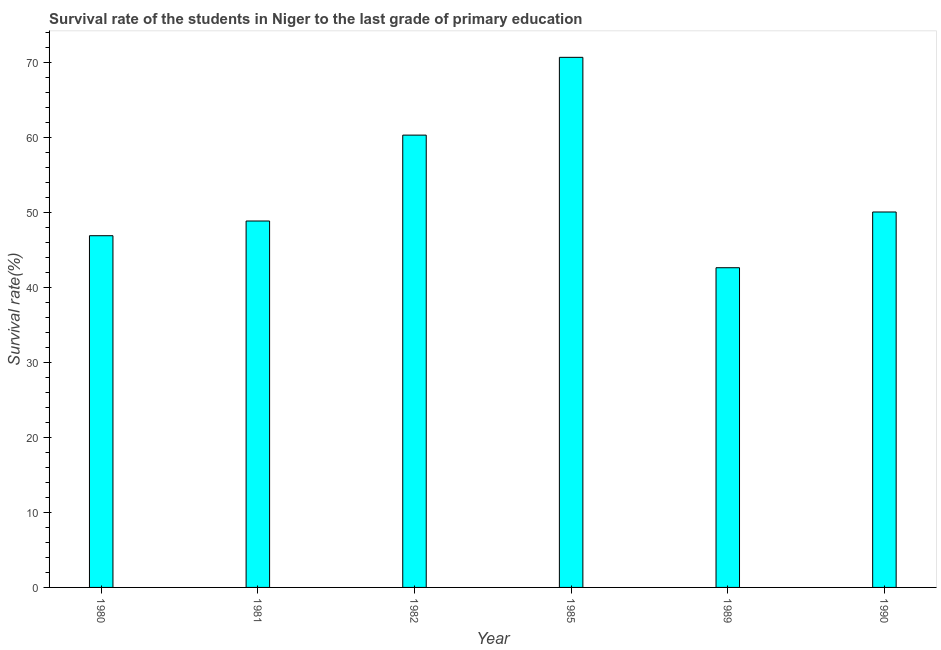Does the graph contain any zero values?
Ensure brevity in your answer.  No. What is the title of the graph?
Provide a short and direct response. Survival rate of the students in Niger to the last grade of primary education. What is the label or title of the X-axis?
Your answer should be very brief. Year. What is the label or title of the Y-axis?
Your answer should be compact. Survival rate(%). What is the survival rate in primary education in 1990?
Provide a succinct answer. 50.06. Across all years, what is the maximum survival rate in primary education?
Provide a succinct answer. 70.68. Across all years, what is the minimum survival rate in primary education?
Provide a short and direct response. 42.63. In which year was the survival rate in primary education minimum?
Your answer should be compact. 1989. What is the sum of the survival rate in primary education?
Offer a very short reply. 319.42. What is the difference between the survival rate in primary education in 1980 and 1982?
Your response must be concise. -13.41. What is the average survival rate in primary education per year?
Keep it short and to the point. 53.24. What is the median survival rate in primary education?
Your response must be concise. 49.46. In how many years, is the survival rate in primary education greater than 4 %?
Offer a very short reply. 6. What is the ratio of the survival rate in primary education in 1980 to that in 1982?
Your response must be concise. 0.78. Is the difference between the survival rate in primary education in 1981 and 1989 greater than the difference between any two years?
Give a very brief answer. No. What is the difference between the highest and the second highest survival rate in primary education?
Ensure brevity in your answer.  10.37. Is the sum of the survival rate in primary education in 1981 and 1982 greater than the maximum survival rate in primary education across all years?
Provide a short and direct response. Yes. What is the difference between the highest and the lowest survival rate in primary education?
Keep it short and to the point. 28.05. How many bars are there?
Keep it short and to the point. 6. Are all the bars in the graph horizontal?
Provide a succinct answer. No. What is the difference between two consecutive major ticks on the Y-axis?
Keep it short and to the point. 10. What is the Survival rate(%) of 1980?
Provide a short and direct response. 46.89. What is the Survival rate(%) in 1981?
Your answer should be compact. 48.85. What is the Survival rate(%) of 1982?
Give a very brief answer. 60.31. What is the Survival rate(%) of 1985?
Your answer should be compact. 70.68. What is the Survival rate(%) in 1989?
Give a very brief answer. 42.63. What is the Survival rate(%) in 1990?
Provide a short and direct response. 50.06. What is the difference between the Survival rate(%) in 1980 and 1981?
Offer a terse response. -1.96. What is the difference between the Survival rate(%) in 1980 and 1982?
Offer a very short reply. -13.41. What is the difference between the Survival rate(%) in 1980 and 1985?
Your answer should be very brief. -23.78. What is the difference between the Survival rate(%) in 1980 and 1989?
Ensure brevity in your answer.  4.27. What is the difference between the Survival rate(%) in 1980 and 1990?
Give a very brief answer. -3.16. What is the difference between the Survival rate(%) in 1981 and 1982?
Offer a terse response. -11.45. What is the difference between the Survival rate(%) in 1981 and 1985?
Offer a very short reply. -21.82. What is the difference between the Survival rate(%) in 1981 and 1989?
Your answer should be very brief. 6.23. What is the difference between the Survival rate(%) in 1981 and 1990?
Give a very brief answer. -1.2. What is the difference between the Survival rate(%) in 1982 and 1985?
Make the answer very short. -10.37. What is the difference between the Survival rate(%) in 1982 and 1989?
Your answer should be very brief. 17.68. What is the difference between the Survival rate(%) in 1982 and 1990?
Your answer should be very brief. 10.25. What is the difference between the Survival rate(%) in 1985 and 1989?
Your answer should be very brief. 28.05. What is the difference between the Survival rate(%) in 1985 and 1990?
Offer a very short reply. 20.62. What is the difference between the Survival rate(%) in 1989 and 1990?
Offer a terse response. -7.43. What is the ratio of the Survival rate(%) in 1980 to that in 1981?
Keep it short and to the point. 0.96. What is the ratio of the Survival rate(%) in 1980 to that in 1982?
Offer a very short reply. 0.78. What is the ratio of the Survival rate(%) in 1980 to that in 1985?
Provide a short and direct response. 0.66. What is the ratio of the Survival rate(%) in 1980 to that in 1989?
Your answer should be very brief. 1.1. What is the ratio of the Survival rate(%) in 1980 to that in 1990?
Make the answer very short. 0.94. What is the ratio of the Survival rate(%) in 1981 to that in 1982?
Your response must be concise. 0.81. What is the ratio of the Survival rate(%) in 1981 to that in 1985?
Make the answer very short. 0.69. What is the ratio of the Survival rate(%) in 1981 to that in 1989?
Keep it short and to the point. 1.15. What is the ratio of the Survival rate(%) in 1982 to that in 1985?
Ensure brevity in your answer.  0.85. What is the ratio of the Survival rate(%) in 1982 to that in 1989?
Your response must be concise. 1.42. What is the ratio of the Survival rate(%) in 1982 to that in 1990?
Your answer should be compact. 1.21. What is the ratio of the Survival rate(%) in 1985 to that in 1989?
Make the answer very short. 1.66. What is the ratio of the Survival rate(%) in 1985 to that in 1990?
Ensure brevity in your answer.  1.41. What is the ratio of the Survival rate(%) in 1989 to that in 1990?
Offer a terse response. 0.85. 